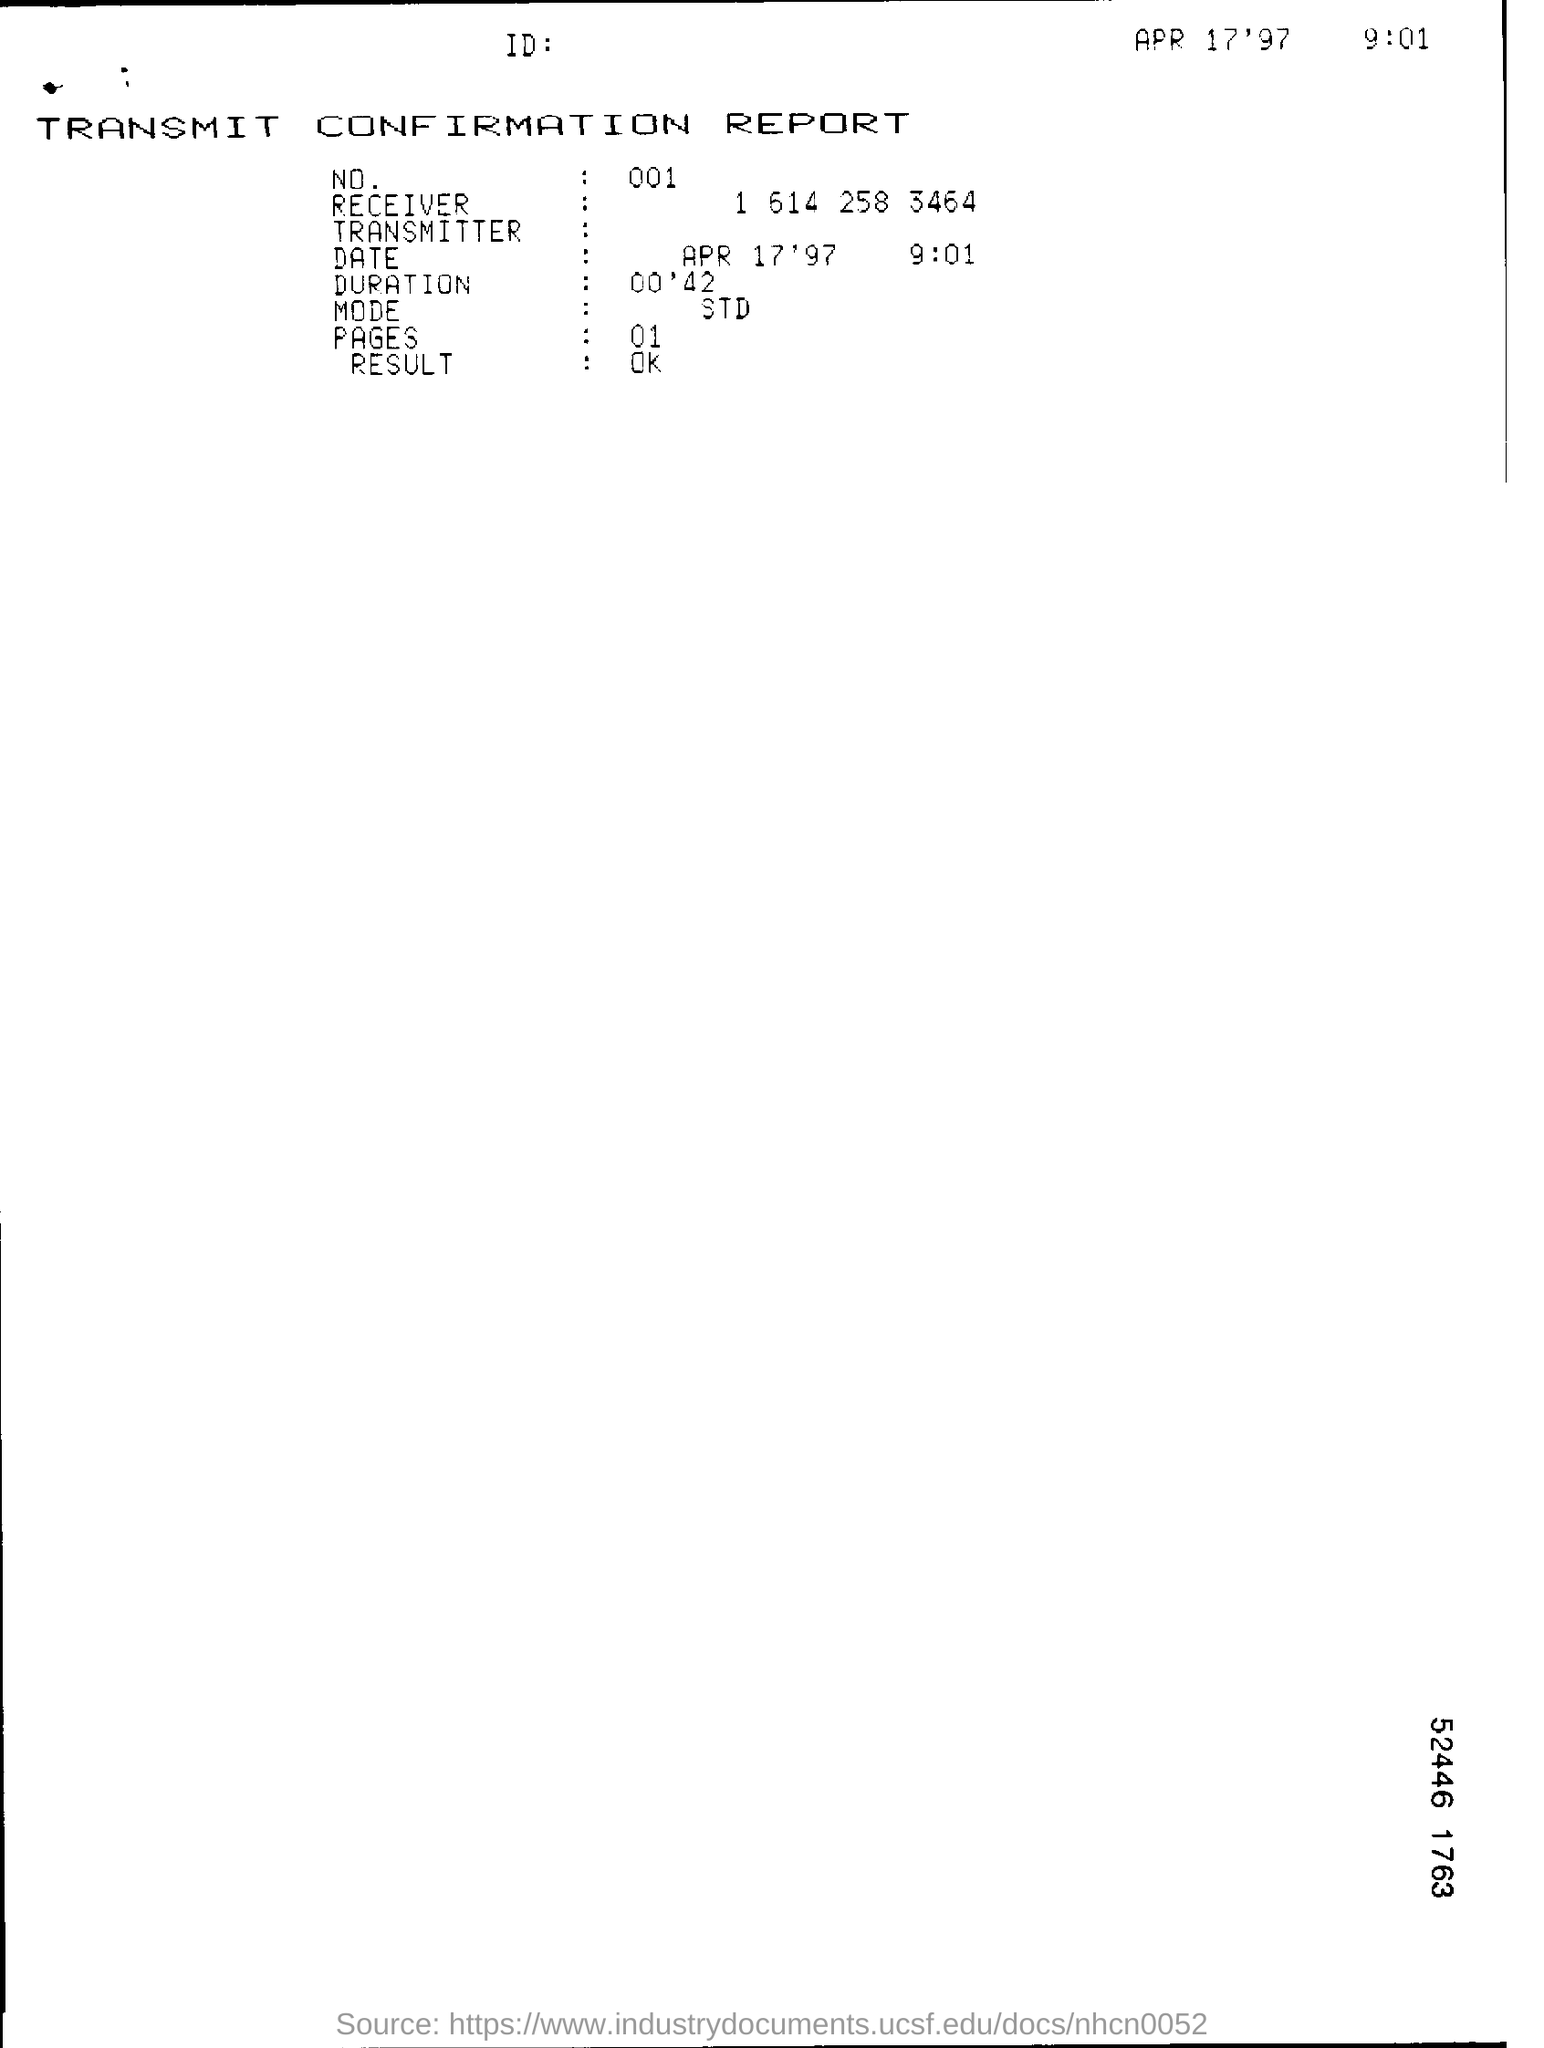What is the NO.?
Your answer should be compact. 001. 